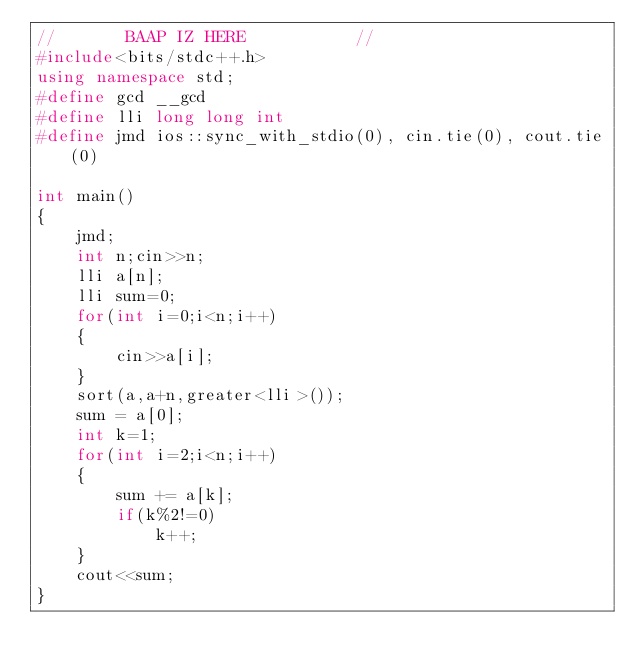<code> <loc_0><loc_0><loc_500><loc_500><_C++_>//       BAAP IZ HERE           //
#include<bits/stdc++.h>
using namespace std;
#define gcd __gcd
#define lli long long int
#define jmd ios::sync_with_stdio(0), cin.tie(0), cout.tie(0)

int main()
{
    jmd;
    int n;cin>>n;
    lli a[n];
    lli sum=0;
    for(int i=0;i<n;i++)
    {
        cin>>a[i];
    }
    sort(a,a+n,greater<lli>());
    sum = a[0];
    int k=1;
    for(int i=2;i<n;i++)
    {
        sum += a[k];
        if(k%2!=0)
            k++;
    }
    cout<<sum;
}</code> 